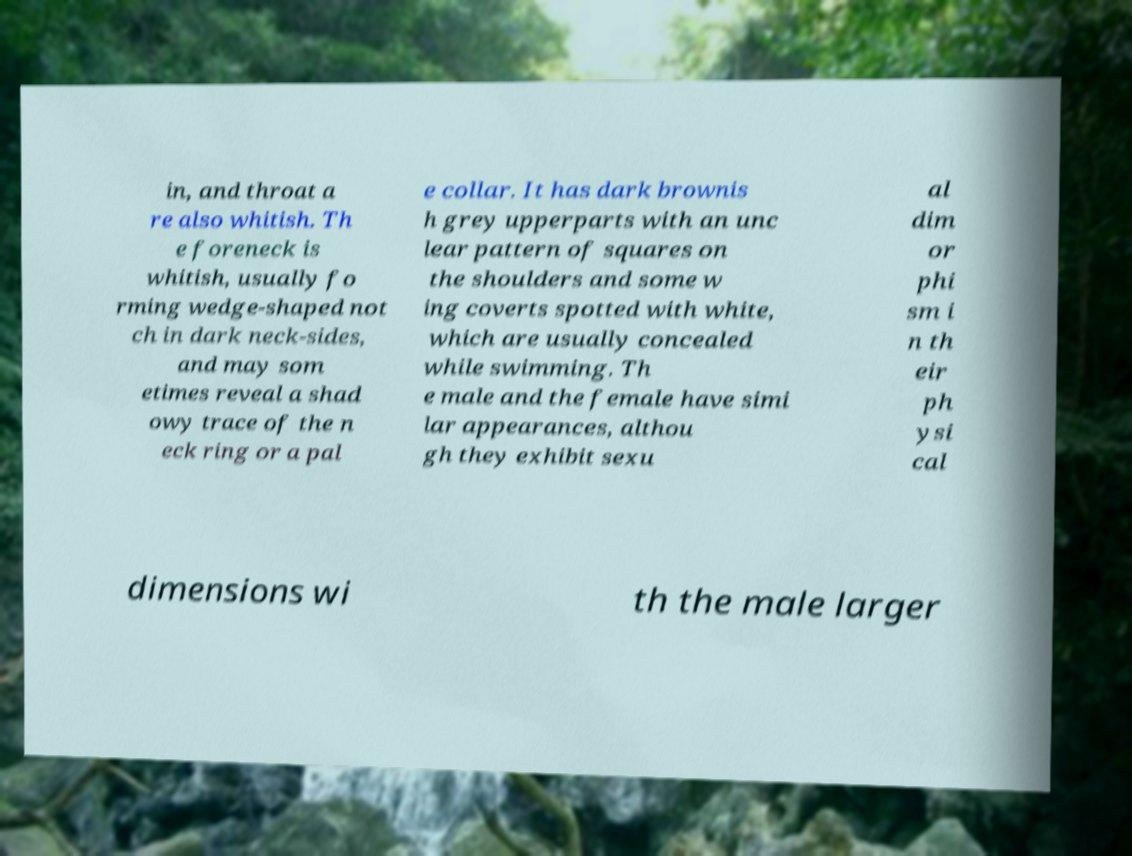Can you read and provide the text displayed in the image?This photo seems to have some interesting text. Can you extract and type it out for me? in, and throat a re also whitish. Th e foreneck is whitish, usually fo rming wedge-shaped not ch in dark neck-sides, and may som etimes reveal a shad owy trace of the n eck ring or a pal e collar. It has dark brownis h grey upperparts with an unc lear pattern of squares on the shoulders and some w ing coverts spotted with white, which are usually concealed while swimming. Th e male and the female have simi lar appearances, althou gh they exhibit sexu al dim or phi sm i n th eir ph ysi cal dimensions wi th the male larger 